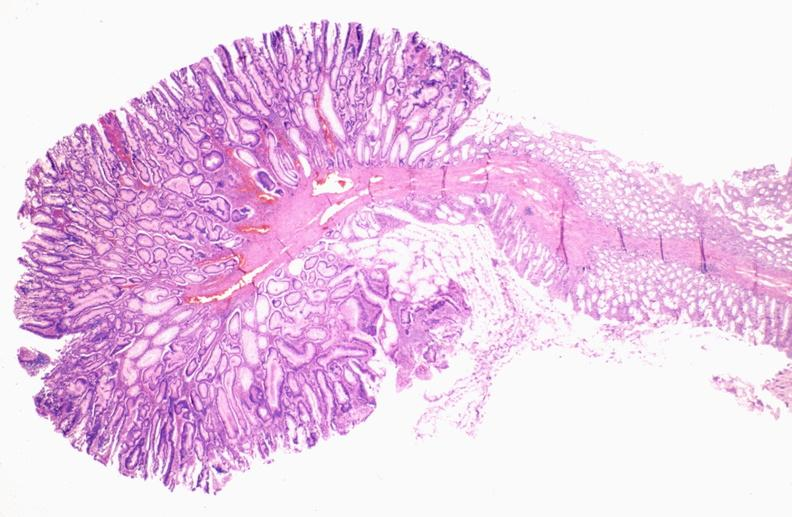does this image show colon, adenomatous polyp?
Answer the question using a single word or phrase. Yes 